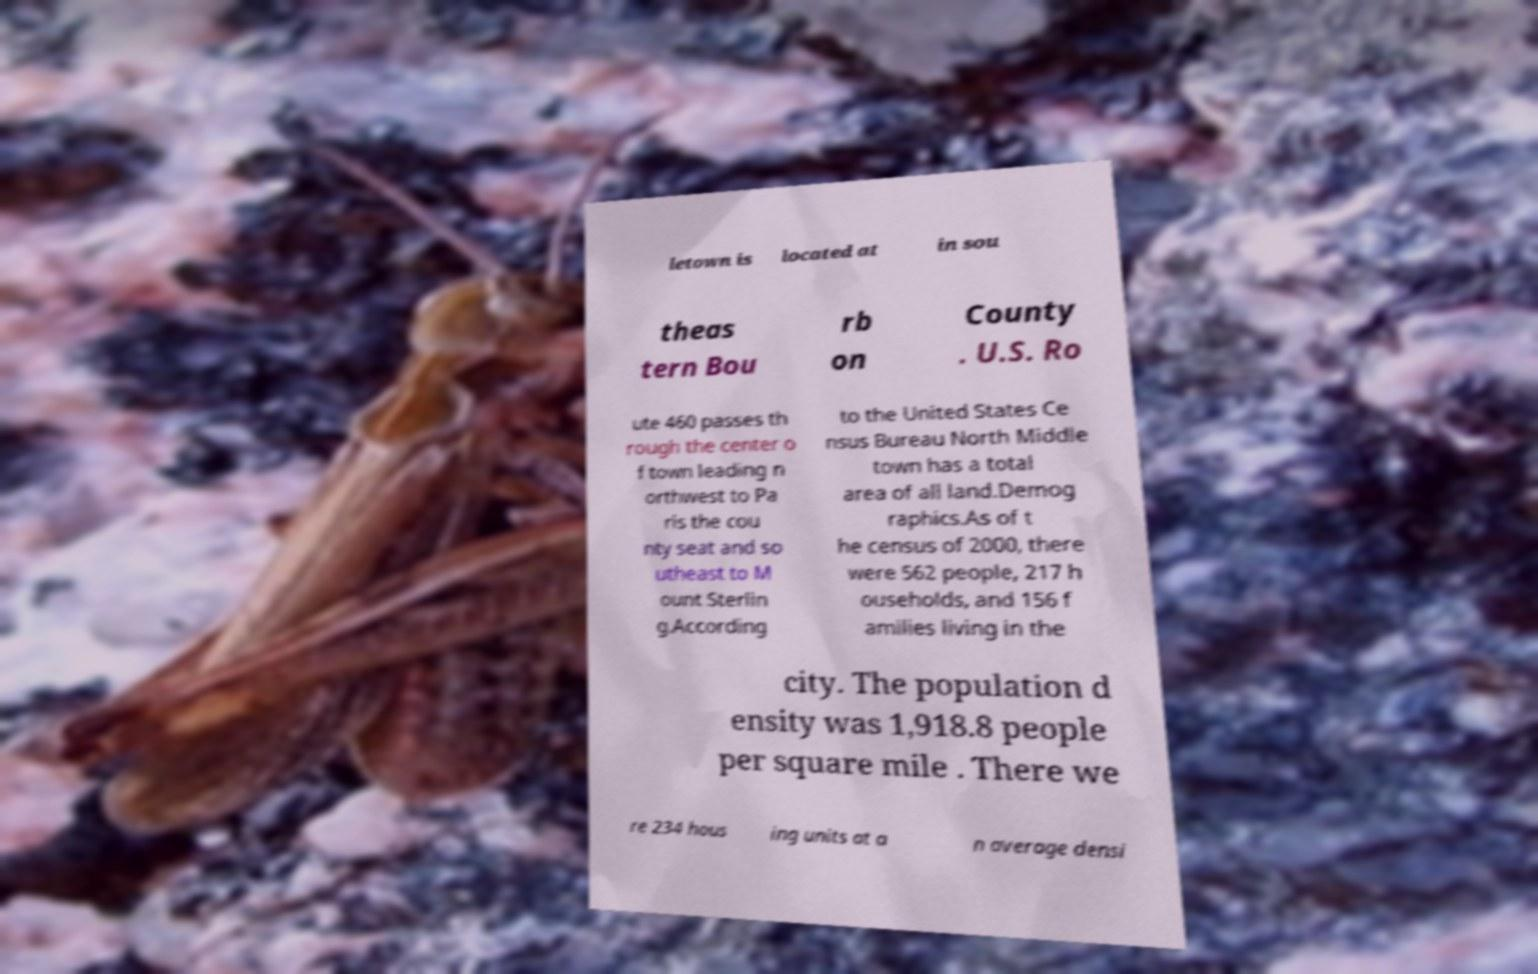What messages or text are displayed in this image? I need them in a readable, typed format. letown is located at in sou theas tern Bou rb on County . U.S. Ro ute 460 passes th rough the center o f town leading n orthwest to Pa ris the cou nty seat and so utheast to M ount Sterlin g.According to the United States Ce nsus Bureau North Middle town has a total area of all land.Demog raphics.As of t he census of 2000, there were 562 people, 217 h ouseholds, and 156 f amilies living in the city. The population d ensity was 1,918.8 people per square mile . There we re 234 hous ing units at a n average densi 